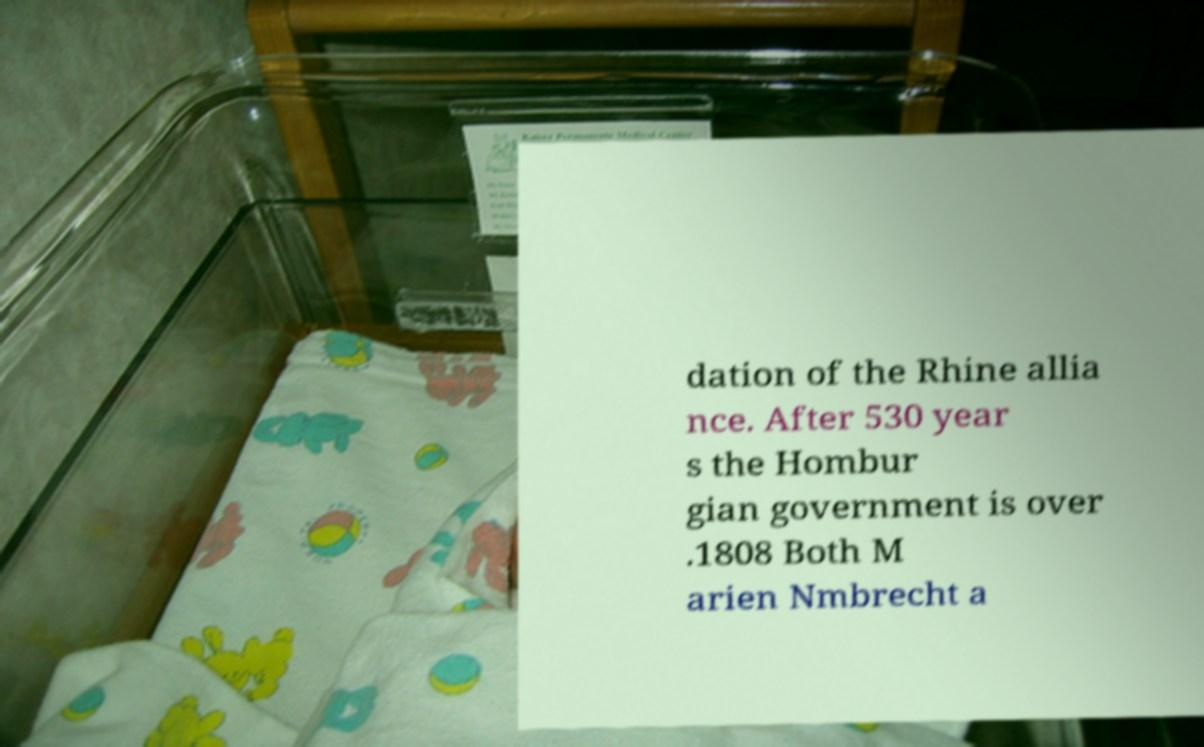There's text embedded in this image that I need extracted. Can you transcribe it verbatim? dation of the Rhine allia nce. After 530 year s the Hombur gian government is over .1808 Both M arien Nmbrecht a 